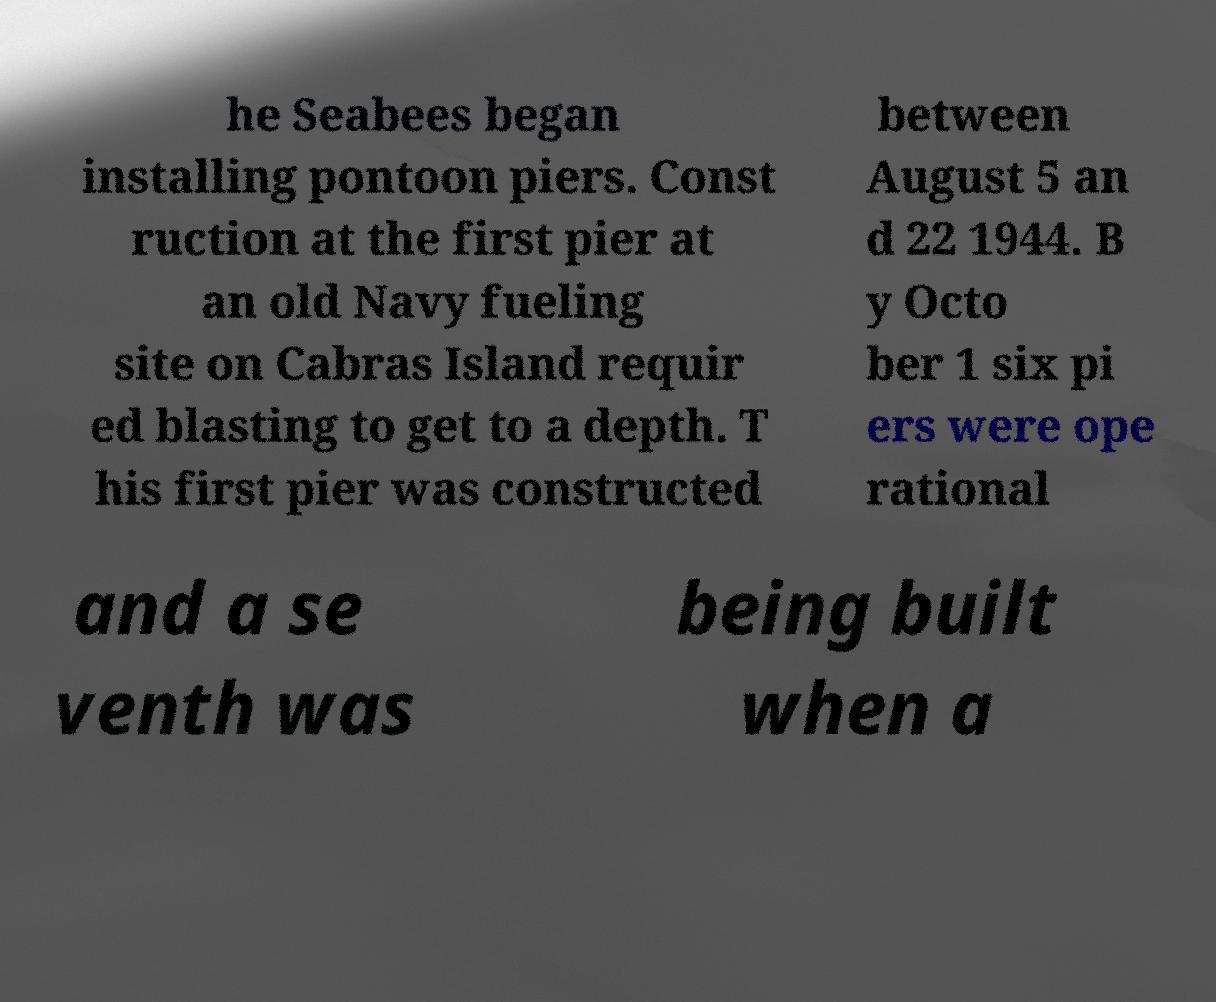Could you assist in decoding the text presented in this image and type it out clearly? he Seabees began installing pontoon piers. Const ruction at the first pier at an old Navy fueling site on Cabras Island requir ed blasting to get to a depth. T his first pier was constructed between August 5 an d 22 1944. B y Octo ber 1 six pi ers were ope rational and a se venth was being built when a 